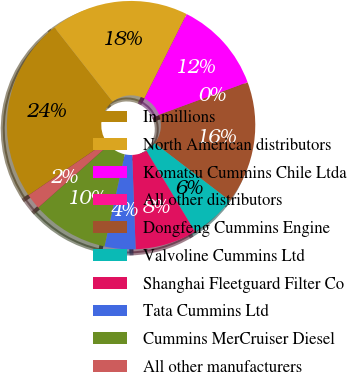Convert chart to OTSL. <chart><loc_0><loc_0><loc_500><loc_500><pie_chart><fcel>In millions<fcel>North American distributors<fcel>Komatsu Cummins Chile Ltda<fcel>All other distributors<fcel>Dongfeng Cummins Engine<fcel>Valvoline Cummins Ltd<fcel>Shanghai Fleetguard Filter Co<fcel>Tata Cummins Ltd<fcel>Cummins MerCruiser Diesel<fcel>All other manufacturers<nl><fcel>23.96%<fcel>17.98%<fcel>11.99%<fcel>0.03%<fcel>15.98%<fcel>6.01%<fcel>8.01%<fcel>4.02%<fcel>10.0%<fcel>2.02%<nl></chart> 